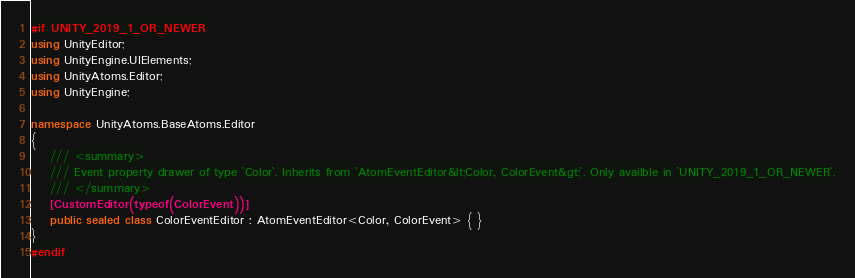Convert code to text. <code><loc_0><loc_0><loc_500><loc_500><_C#_>#if UNITY_2019_1_OR_NEWER
using UnityEditor;
using UnityEngine.UIElements;
using UnityAtoms.Editor;
using UnityEngine;

namespace UnityAtoms.BaseAtoms.Editor
{
    /// <summary>
    /// Event property drawer of type `Color`. Inherits from `AtomEventEditor&lt;Color, ColorEvent&gt;`. Only availble in `UNITY_2019_1_OR_NEWER`.
    /// </summary>
    [CustomEditor(typeof(ColorEvent))]
    public sealed class ColorEventEditor : AtomEventEditor<Color, ColorEvent> { }
}
#endif
</code> 